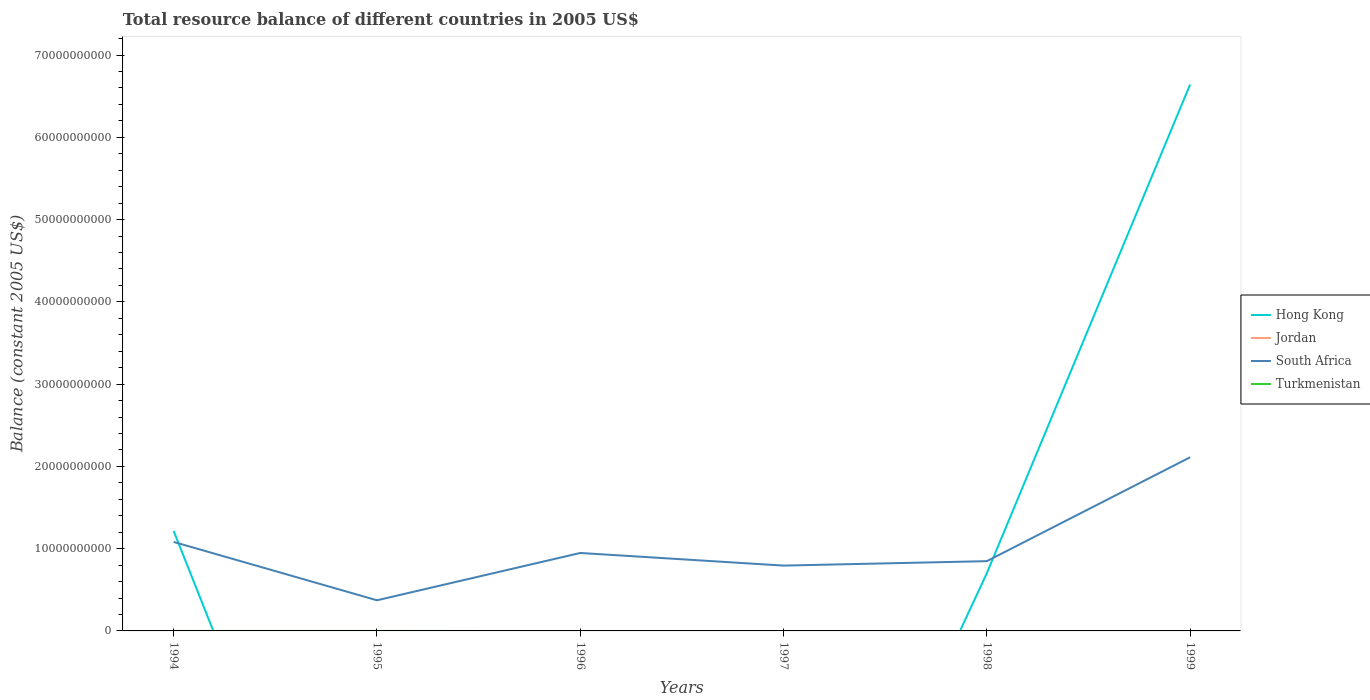How many different coloured lines are there?
Make the answer very short. 2. Does the line corresponding to Hong Kong intersect with the line corresponding to South Africa?
Keep it short and to the point. Yes. Is the number of lines equal to the number of legend labels?
Provide a succinct answer. No. What is the total total resource balance in South Africa in the graph?
Ensure brevity in your answer.  -1.26e+1. What is the difference between the highest and the second highest total resource balance in Hong Kong?
Your response must be concise. 6.64e+1. What is the difference between two consecutive major ticks on the Y-axis?
Your response must be concise. 1.00e+1. Does the graph contain any zero values?
Your answer should be compact. Yes. How are the legend labels stacked?
Your response must be concise. Vertical. What is the title of the graph?
Provide a succinct answer. Total resource balance of different countries in 2005 US$. Does "East Asia (all income levels)" appear as one of the legend labels in the graph?
Your answer should be very brief. No. What is the label or title of the Y-axis?
Make the answer very short. Balance (constant 2005 US$). What is the Balance (constant 2005 US$) in Hong Kong in 1994?
Provide a short and direct response. 1.21e+1. What is the Balance (constant 2005 US$) of Jordan in 1994?
Ensure brevity in your answer.  0. What is the Balance (constant 2005 US$) of South Africa in 1994?
Your response must be concise. 1.08e+1. What is the Balance (constant 2005 US$) of South Africa in 1995?
Offer a very short reply. 3.72e+09. What is the Balance (constant 2005 US$) in Turkmenistan in 1995?
Provide a short and direct response. 0. What is the Balance (constant 2005 US$) of Hong Kong in 1996?
Provide a succinct answer. 0. What is the Balance (constant 2005 US$) of Jordan in 1996?
Your answer should be very brief. 0. What is the Balance (constant 2005 US$) in South Africa in 1996?
Keep it short and to the point. 9.48e+09. What is the Balance (constant 2005 US$) in Turkmenistan in 1996?
Make the answer very short. 0. What is the Balance (constant 2005 US$) of South Africa in 1997?
Keep it short and to the point. 7.94e+09. What is the Balance (constant 2005 US$) of Hong Kong in 1998?
Your answer should be compact. 7.01e+09. What is the Balance (constant 2005 US$) in South Africa in 1998?
Provide a succinct answer. 8.48e+09. What is the Balance (constant 2005 US$) of Hong Kong in 1999?
Offer a terse response. 6.64e+1. What is the Balance (constant 2005 US$) in South Africa in 1999?
Your response must be concise. 2.11e+1. Across all years, what is the maximum Balance (constant 2005 US$) in Hong Kong?
Make the answer very short. 6.64e+1. Across all years, what is the maximum Balance (constant 2005 US$) of South Africa?
Offer a terse response. 2.11e+1. Across all years, what is the minimum Balance (constant 2005 US$) of Hong Kong?
Provide a short and direct response. 0. Across all years, what is the minimum Balance (constant 2005 US$) in South Africa?
Keep it short and to the point. 3.72e+09. What is the total Balance (constant 2005 US$) in Hong Kong in the graph?
Give a very brief answer. 8.56e+1. What is the total Balance (constant 2005 US$) of South Africa in the graph?
Provide a short and direct response. 6.15e+1. What is the total Balance (constant 2005 US$) in Turkmenistan in the graph?
Keep it short and to the point. 0. What is the difference between the Balance (constant 2005 US$) of South Africa in 1994 and that in 1995?
Provide a short and direct response. 7.09e+09. What is the difference between the Balance (constant 2005 US$) in South Africa in 1994 and that in 1996?
Keep it short and to the point. 1.34e+09. What is the difference between the Balance (constant 2005 US$) of South Africa in 1994 and that in 1997?
Ensure brevity in your answer.  2.87e+09. What is the difference between the Balance (constant 2005 US$) in Hong Kong in 1994 and that in 1998?
Your answer should be very brief. 5.13e+09. What is the difference between the Balance (constant 2005 US$) in South Africa in 1994 and that in 1998?
Provide a short and direct response. 2.33e+09. What is the difference between the Balance (constant 2005 US$) of Hong Kong in 1994 and that in 1999?
Your answer should be very brief. -5.43e+1. What is the difference between the Balance (constant 2005 US$) of South Africa in 1994 and that in 1999?
Ensure brevity in your answer.  -1.03e+1. What is the difference between the Balance (constant 2005 US$) of South Africa in 1995 and that in 1996?
Your response must be concise. -5.75e+09. What is the difference between the Balance (constant 2005 US$) of South Africa in 1995 and that in 1997?
Keep it short and to the point. -4.22e+09. What is the difference between the Balance (constant 2005 US$) in South Africa in 1995 and that in 1998?
Offer a very short reply. -4.76e+09. What is the difference between the Balance (constant 2005 US$) of South Africa in 1995 and that in 1999?
Ensure brevity in your answer.  -1.74e+1. What is the difference between the Balance (constant 2005 US$) in South Africa in 1996 and that in 1997?
Offer a very short reply. 1.54e+09. What is the difference between the Balance (constant 2005 US$) in South Africa in 1996 and that in 1998?
Your answer should be very brief. 9.95e+08. What is the difference between the Balance (constant 2005 US$) of South Africa in 1996 and that in 1999?
Offer a very short reply. -1.16e+1. What is the difference between the Balance (constant 2005 US$) of South Africa in 1997 and that in 1998?
Make the answer very short. -5.40e+08. What is the difference between the Balance (constant 2005 US$) in South Africa in 1997 and that in 1999?
Offer a very short reply. -1.32e+1. What is the difference between the Balance (constant 2005 US$) in Hong Kong in 1998 and that in 1999?
Keep it short and to the point. -5.94e+1. What is the difference between the Balance (constant 2005 US$) in South Africa in 1998 and that in 1999?
Ensure brevity in your answer.  -1.26e+1. What is the difference between the Balance (constant 2005 US$) of Hong Kong in 1994 and the Balance (constant 2005 US$) of South Africa in 1995?
Your answer should be very brief. 8.42e+09. What is the difference between the Balance (constant 2005 US$) in Hong Kong in 1994 and the Balance (constant 2005 US$) in South Africa in 1996?
Ensure brevity in your answer.  2.67e+09. What is the difference between the Balance (constant 2005 US$) of Hong Kong in 1994 and the Balance (constant 2005 US$) of South Africa in 1997?
Ensure brevity in your answer.  4.20e+09. What is the difference between the Balance (constant 2005 US$) in Hong Kong in 1994 and the Balance (constant 2005 US$) in South Africa in 1998?
Offer a terse response. 3.66e+09. What is the difference between the Balance (constant 2005 US$) in Hong Kong in 1994 and the Balance (constant 2005 US$) in South Africa in 1999?
Keep it short and to the point. -8.96e+09. What is the difference between the Balance (constant 2005 US$) in Hong Kong in 1998 and the Balance (constant 2005 US$) in South Africa in 1999?
Your response must be concise. -1.41e+1. What is the average Balance (constant 2005 US$) of Hong Kong per year?
Provide a succinct answer. 1.43e+1. What is the average Balance (constant 2005 US$) of South Africa per year?
Your response must be concise. 1.03e+1. In the year 1994, what is the difference between the Balance (constant 2005 US$) of Hong Kong and Balance (constant 2005 US$) of South Africa?
Make the answer very short. 1.33e+09. In the year 1998, what is the difference between the Balance (constant 2005 US$) in Hong Kong and Balance (constant 2005 US$) in South Africa?
Your answer should be very brief. -1.47e+09. In the year 1999, what is the difference between the Balance (constant 2005 US$) of Hong Kong and Balance (constant 2005 US$) of South Africa?
Offer a very short reply. 4.53e+1. What is the ratio of the Balance (constant 2005 US$) of South Africa in 1994 to that in 1995?
Make the answer very short. 2.9. What is the ratio of the Balance (constant 2005 US$) in South Africa in 1994 to that in 1996?
Your answer should be compact. 1.14. What is the ratio of the Balance (constant 2005 US$) of South Africa in 1994 to that in 1997?
Your answer should be compact. 1.36. What is the ratio of the Balance (constant 2005 US$) in Hong Kong in 1994 to that in 1998?
Your answer should be very brief. 1.73. What is the ratio of the Balance (constant 2005 US$) of South Africa in 1994 to that in 1998?
Ensure brevity in your answer.  1.28. What is the ratio of the Balance (constant 2005 US$) of Hong Kong in 1994 to that in 1999?
Offer a terse response. 0.18. What is the ratio of the Balance (constant 2005 US$) of South Africa in 1994 to that in 1999?
Provide a succinct answer. 0.51. What is the ratio of the Balance (constant 2005 US$) in South Africa in 1995 to that in 1996?
Keep it short and to the point. 0.39. What is the ratio of the Balance (constant 2005 US$) of South Africa in 1995 to that in 1997?
Your answer should be compact. 0.47. What is the ratio of the Balance (constant 2005 US$) of South Africa in 1995 to that in 1998?
Make the answer very short. 0.44. What is the ratio of the Balance (constant 2005 US$) of South Africa in 1995 to that in 1999?
Ensure brevity in your answer.  0.18. What is the ratio of the Balance (constant 2005 US$) of South Africa in 1996 to that in 1997?
Provide a short and direct response. 1.19. What is the ratio of the Balance (constant 2005 US$) in South Africa in 1996 to that in 1998?
Offer a terse response. 1.12. What is the ratio of the Balance (constant 2005 US$) of South Africa in 1996 to that in 1999?
Offer a terse response. 0.45. What is the ratio of the Balance (constant 2005 US$) in South Africa in 1997 to that in 1998?
Ensure brevity in your answer.  0.94. What is the ratio of the Balance (constant 2005 US$) of South Africa in 1997 to that in 1999?
Offer a very short reply. 0.38. What is the ratio of the Balance (constant 2005 US$) of Hong Kong in 1998 to that in 1999?
Provide a short and direct response. 0.11. What is the ratio of the Balance (constant 2005 US$) in South Africa in 1998 to that in 1999?
Keep it short and to the point. 0.4. What is the difference between the highest and the second highest Balance (constant 2005 US$) in Hong Kong?
Your answer should be very brief. 5.43e+1. What is the difference between the highest and the second highest Balance (constant 2005 US$) of South Africa?
Keep it short and to the point. 1.03e+1. What is the difference between the highest and the lowest Balance (constant 2005 US$) in Hong Kong?
Make the answer very short. 6.64e+1. What is the difference between the highest and the lowest Balance (constant 2005 US$) in South Africa?
Your answer should be very brief. 1.74e+1. 